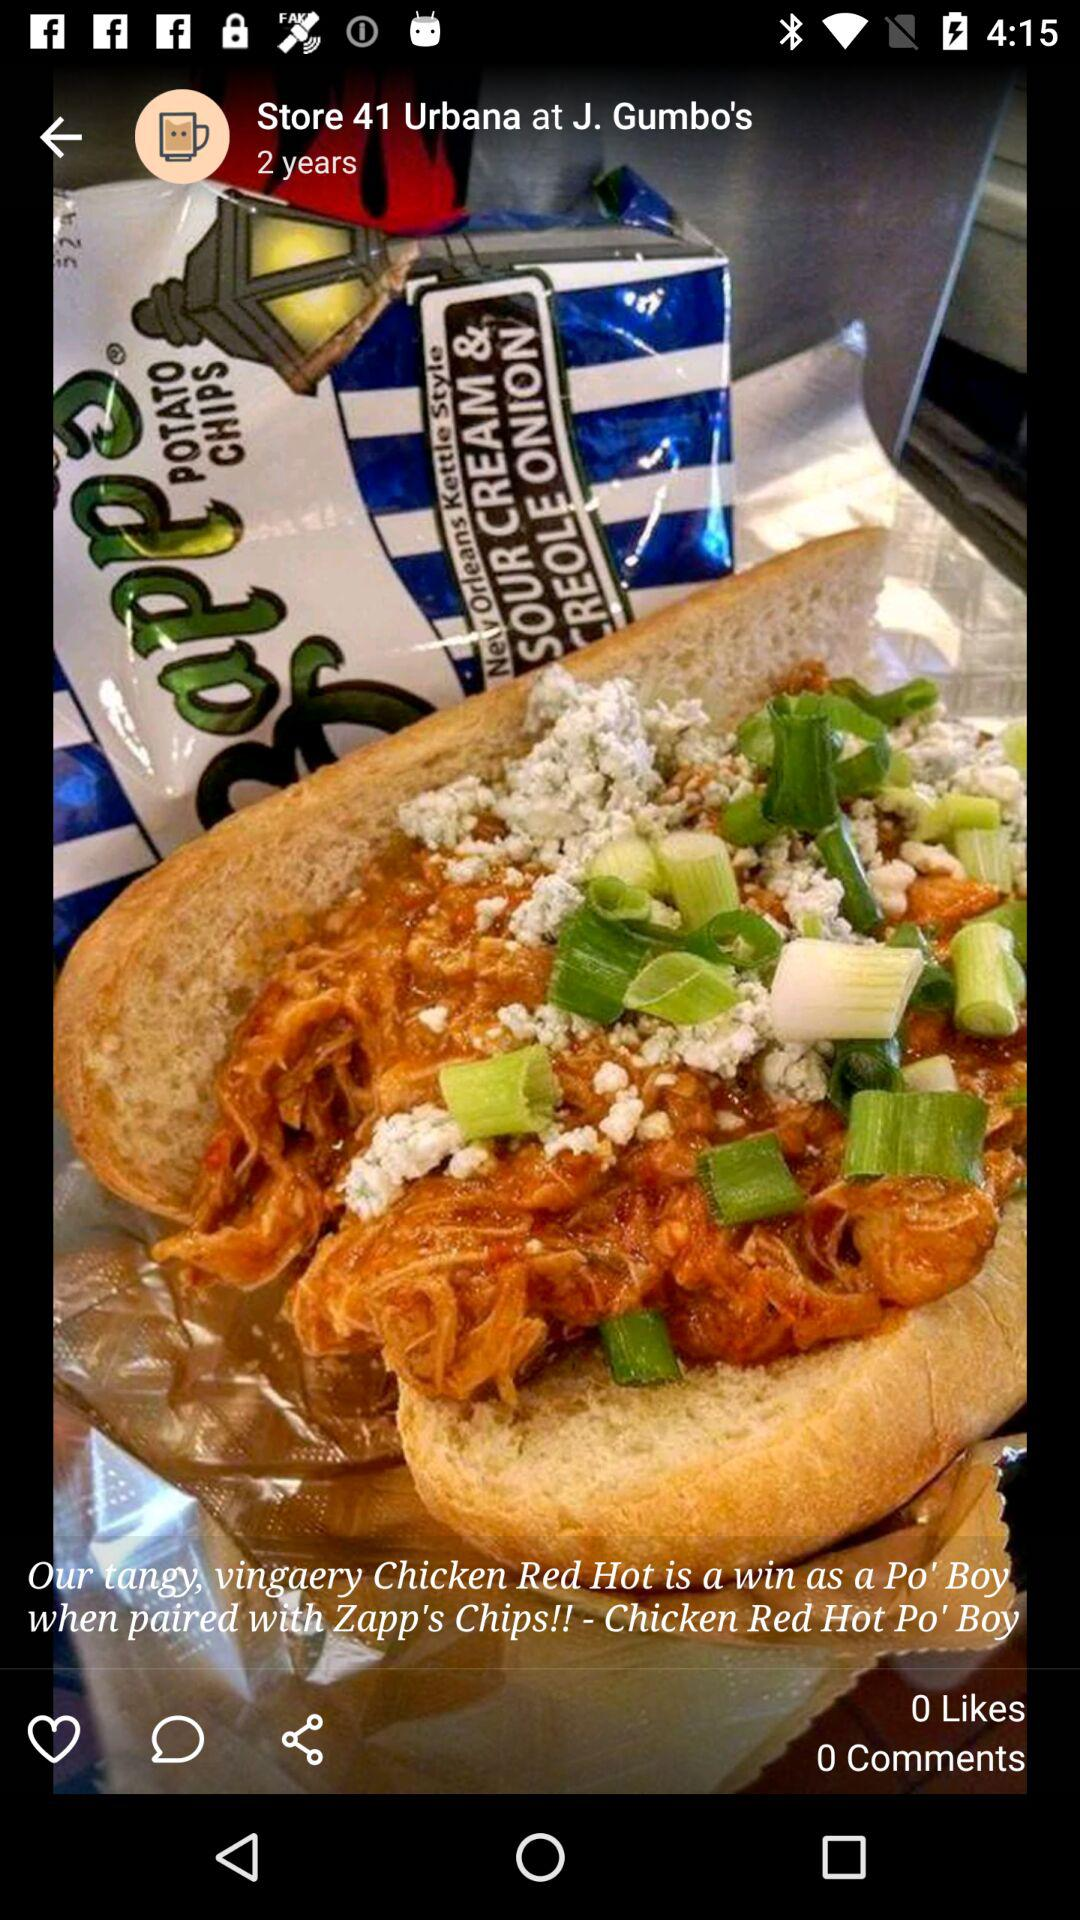How many likes are there? There are 0 likes. 